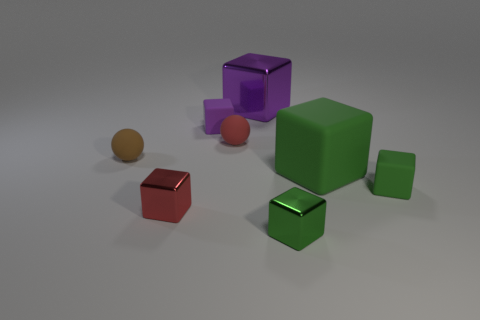What number of purple shiny things have the same shape as the purple rubber thing?
Your response must be concise. 1. Are there the same number of small red cubes that are behind the tiny green rubber block and green matte things that are left of the brown sphere?
Offer a terse response. Yes. Are any large purple objects visible?
Your response must be concise. Yes. There is a purple object that is left of the large thing behind the small cube that is behind the red rubber thing; what is its size?
Your response must be concise. Small. What shape is the other object that is the same size as the purple metallic object?
Your answer should be compact. Cube. Are there any other things that are made of the same material as the red block?
Provide a succinct answer. Yes. What number of things are small cubes that are behind the small green shiny thing or matte things?
Your answer should be compact. 6. Is there a small thing that is on the right side of the red thing left of the small red object that is behind the tiny red metal thing?
Make the answer very short. Yes. What number of metallic cubes are there?
Offer a very short reply. 3. What number of things are cubes that are right of the tiny green metal cube or rubber things that are in front of the red matte sphere?
Keep it short and to the point. 3. 